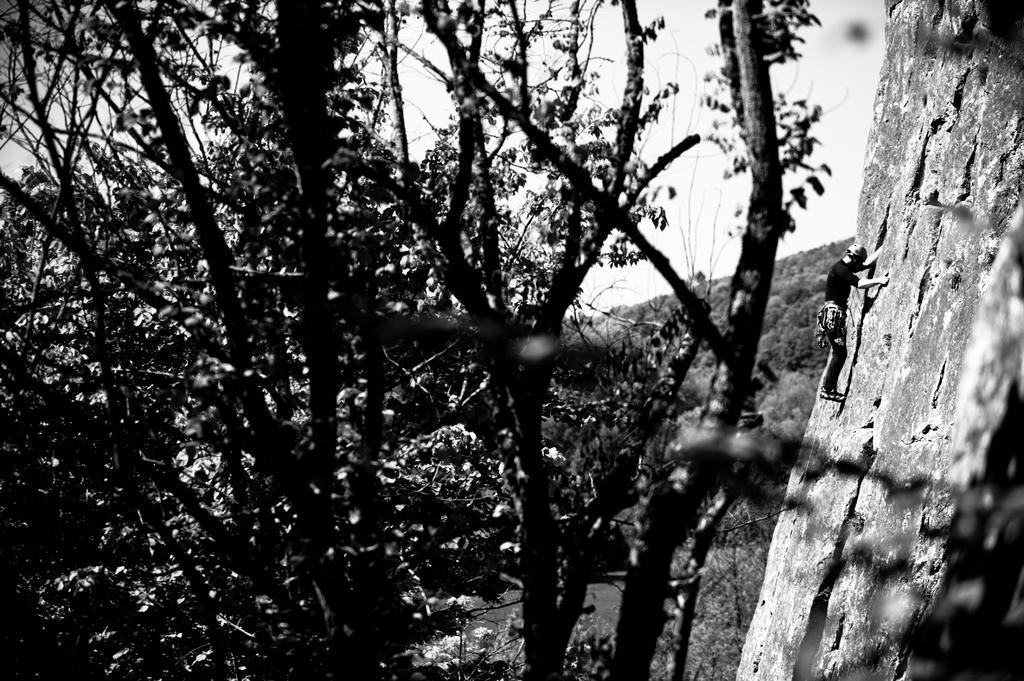In one or two sentences, can you explain what this image depicts? In the picture we can see a part of the tree and beside it, we can see a part of the rock mountain with a person climbing on it and beside it, we can see a hill and on the top of it we can see the part of the sky. 